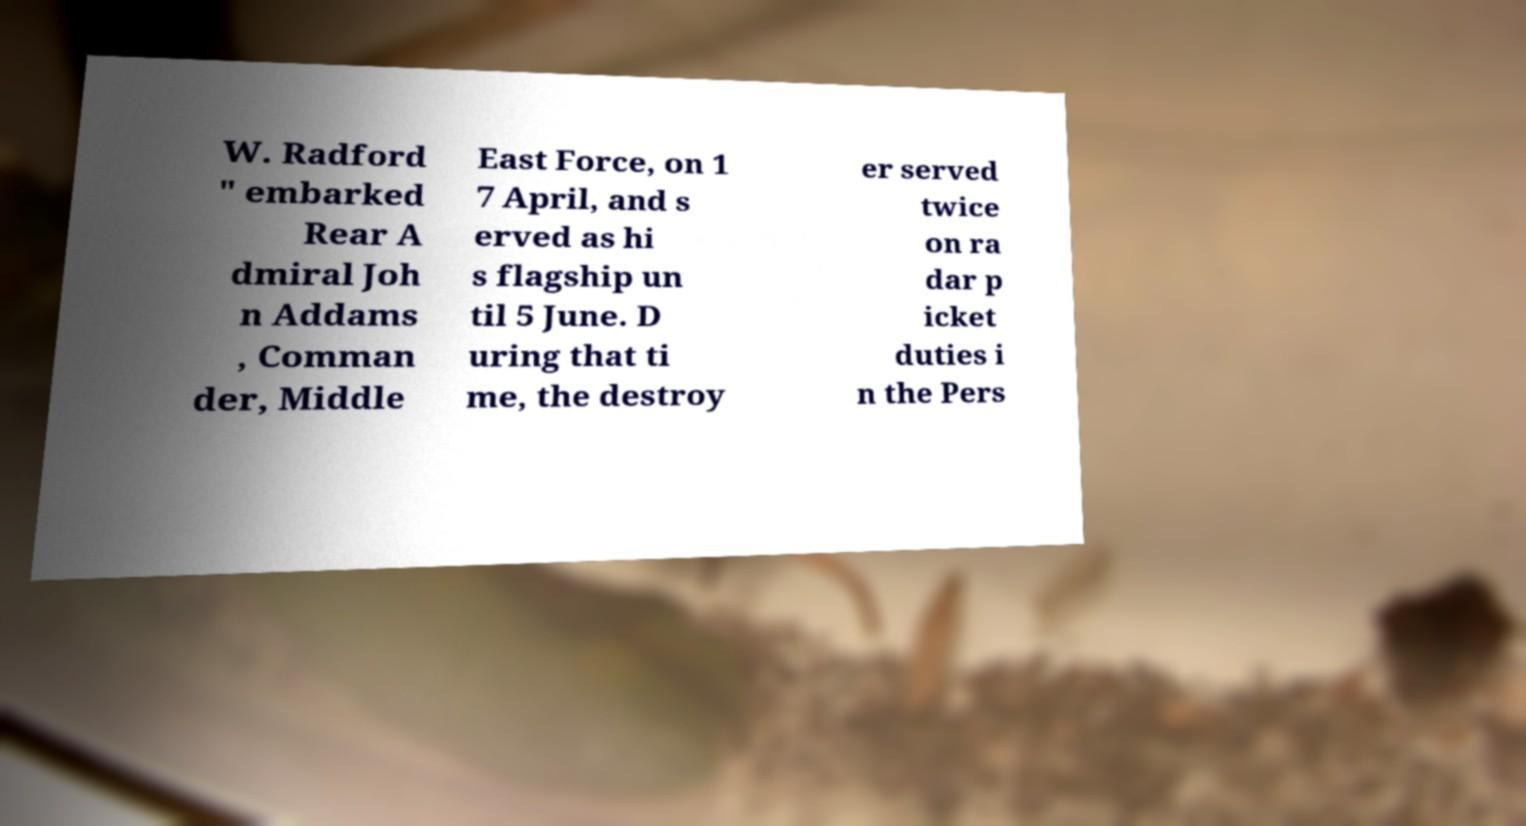Can you accurately transcribe the text from the provided image for me? W. Radford " embarked Rear A dmiral Joh n Addams , Comman der, Middle East Force, on 1 7 April, and s erved as hi s flagship un til 5 June. D uring that ti me, the destroy er served twice on ra dar p icket duties i n the Pers 